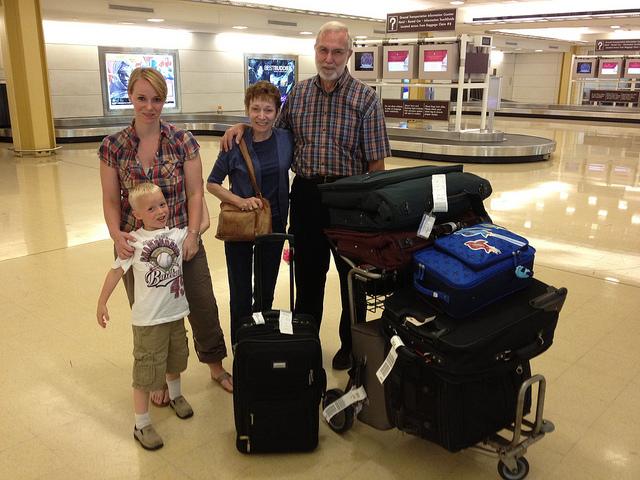How many children are in the picture?
Answer briefly. 1. Do these people know each other?
Be succinct. Yes. How much luggage is here?
Write a very short answer. 6. What does the woman on the left have on her back?
Concise answer only. Nothing. 